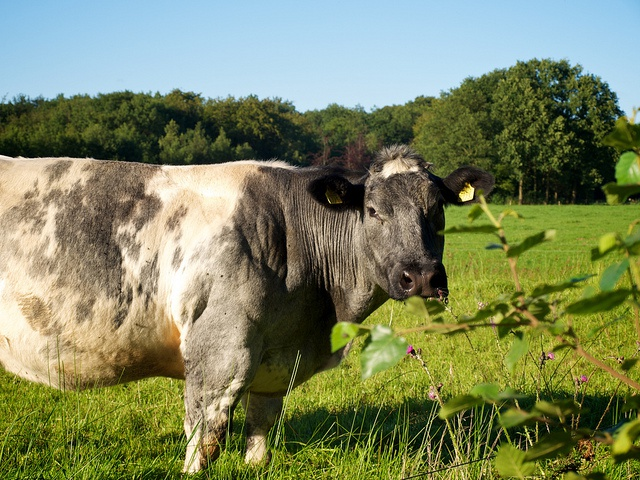Describe the objects in this image and their specific colors. I can see a cow in lightblue, black, tan, and beige tones in this image. 